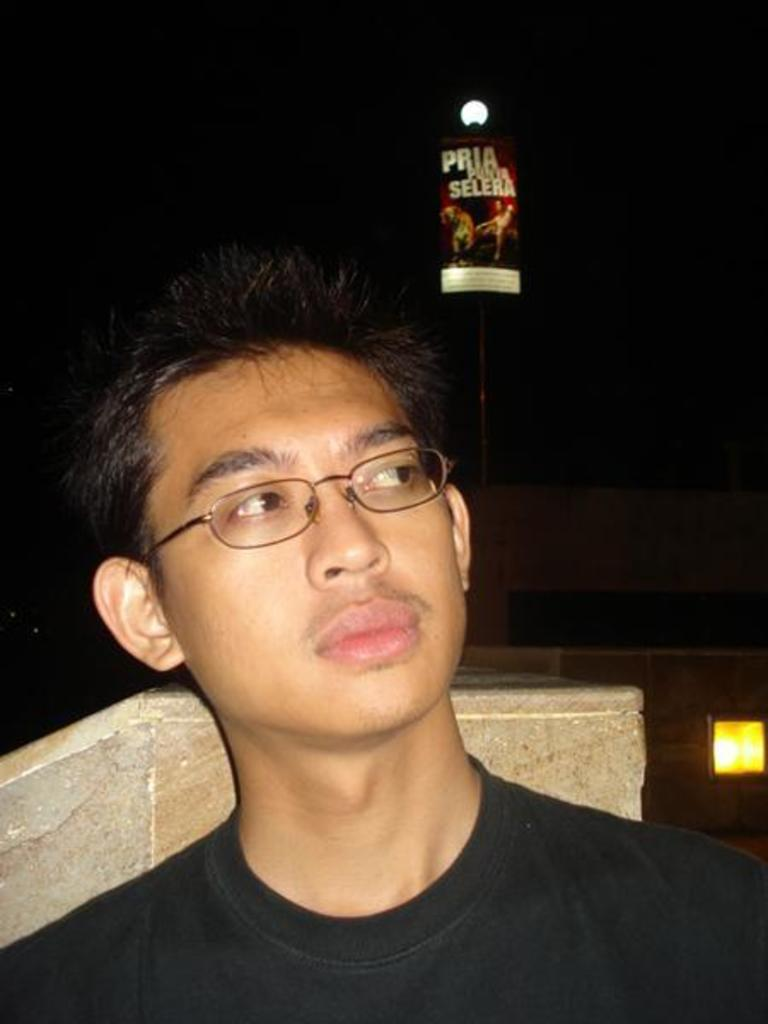Who or what is present in the image? There is a person in the image. Can you describe the person's appearance? The person is wearing glasses. What can be seen in the background of the image? There are lights and a board in the background of the image. What object is visible in the image? There is a stand in the image. What type of crown is the person wearing in the image? There is no crown present in the image; the person is wearing glasses. How many crates are visible in the image? There are no crates present in the image. 